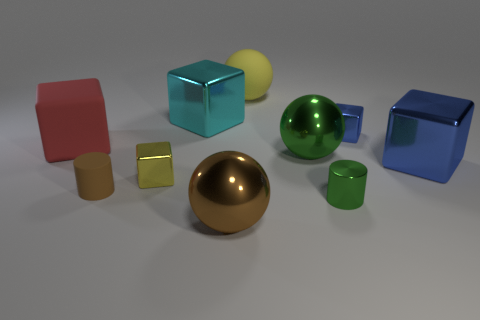Subtract all yellow blocks. How many blocks are left? 4 Subtract all yellow balls. How many balls are left? 2 Subtract 3 balls. How many balls are left? 0 Subtract all blue cylinders. Subtract all brown cubes. How many cylinders are left? 2 Subtract 0 cyan balls. How many objects are left? 10 Subtract all cylinders. How many objects are left? 8 Subtract all yellow balls. How many blue blocks are left? 2 Subtract all yellow blocks. Subtract all large cyan blocks. How many objects are left? 8 Add 9 yellow spheres. How many yellow spheres are left? 10 Add 8 purple spheres. How many purple spheres exist? 8 